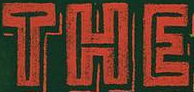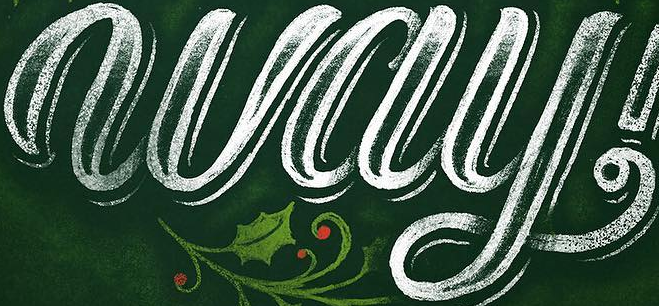Transcribe the words shown in these images in order, separated by a semicolon. THE; way 